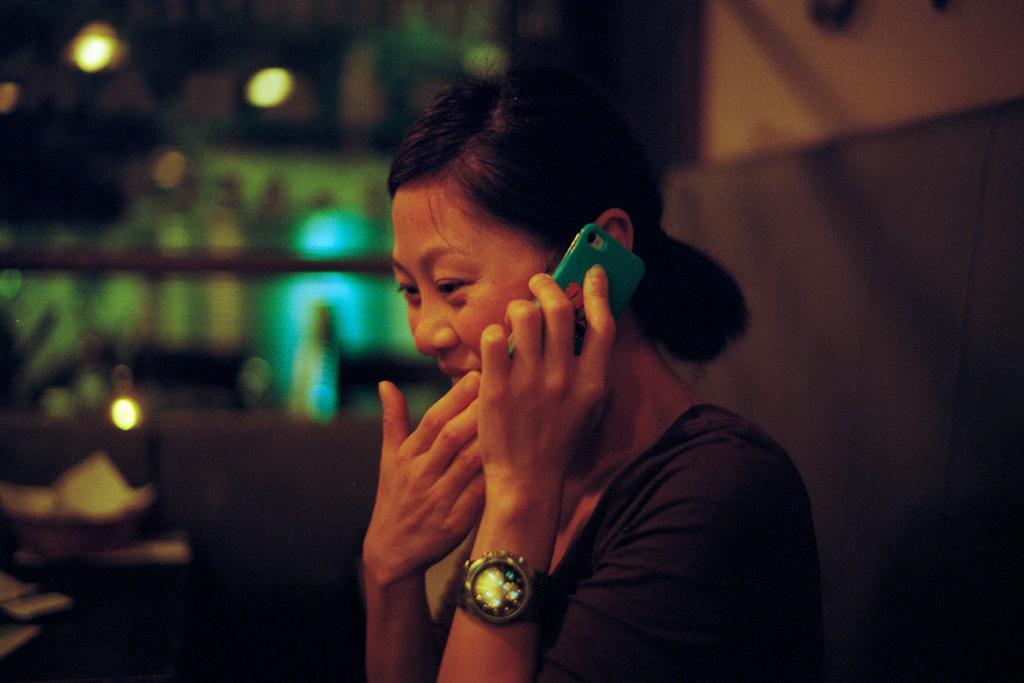Can you describe this image briefly? In this image, we can see a woman is holding a mobile and wearing a watch. Background there is a blur view. Here we can see the lights. 